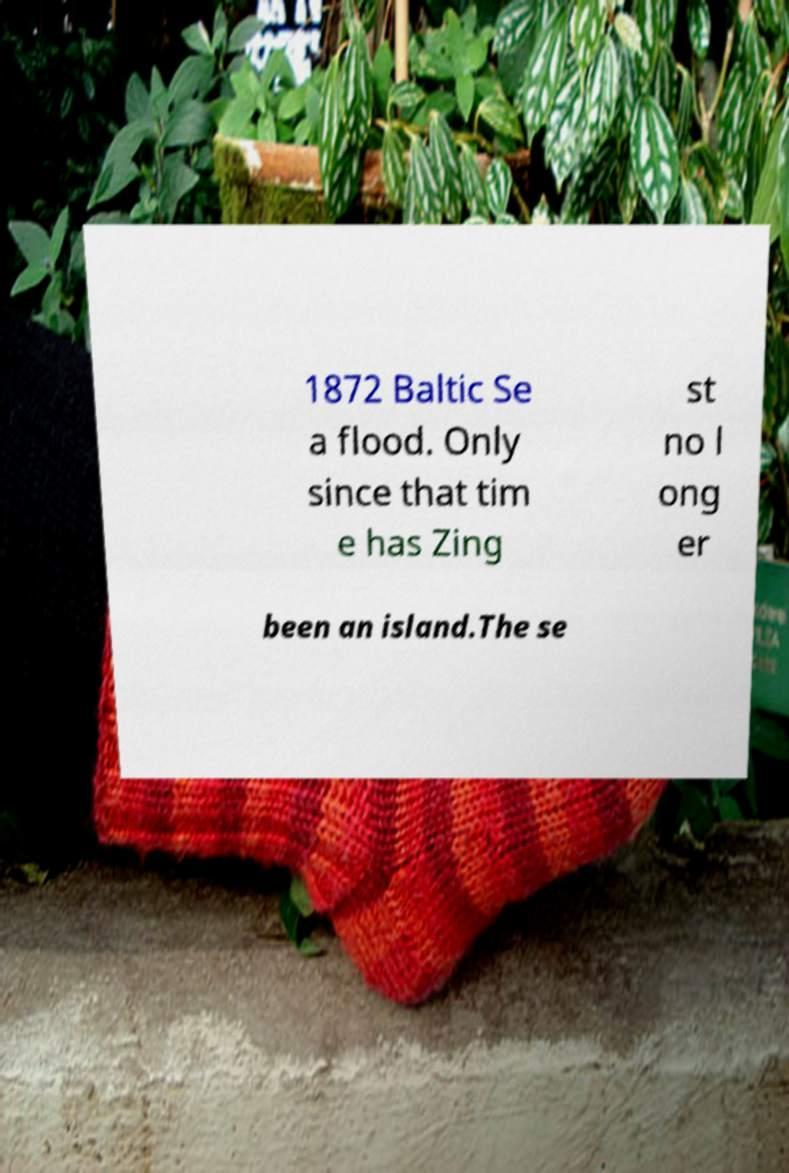I need the written content from this picture converted into text. Can you do that? 1872 Baltic Se a flood. Only since that tim e has Zing st no l ong er been an island.The se 